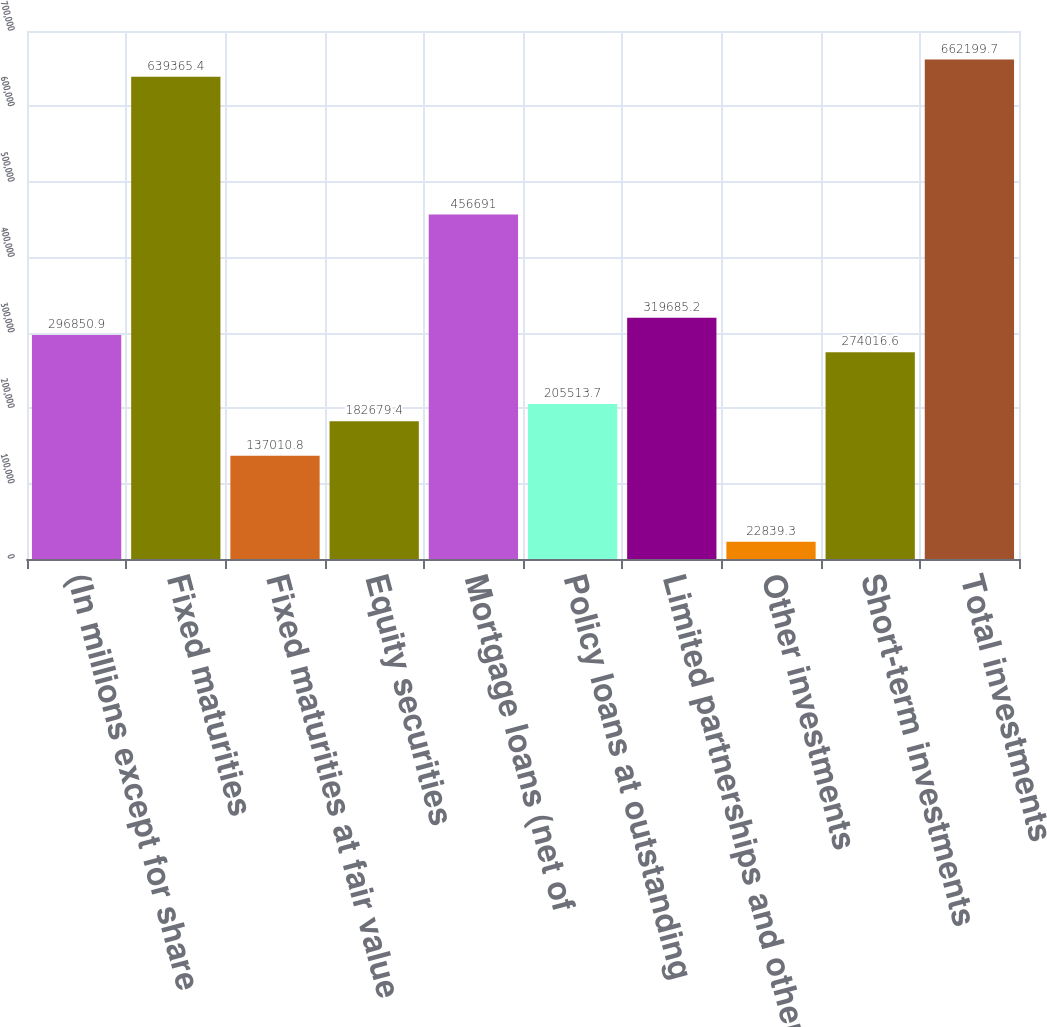<chart> <loc_0><loc_0><loc_500><loc_500><bar_chart><fcel>(In millions except for share<fcel>Fixed maturities<fcel>Fixed maturities at fair value<fcel>Equity securities<fcel>Mortgage loans (net of<fcel>Policy loans at outstanding<fcel>Limited partnerships and other<fcel>Other investments<fcel>Short-term investments<fcel>Total investments<nl><fcel>296851<fcel>639365<fcel>137011<fcel>182679<fcel>456691<fcel>205514<fcel>319685<fcel>22839.3<fcel>274017<fcel>662200<nl></chart> 